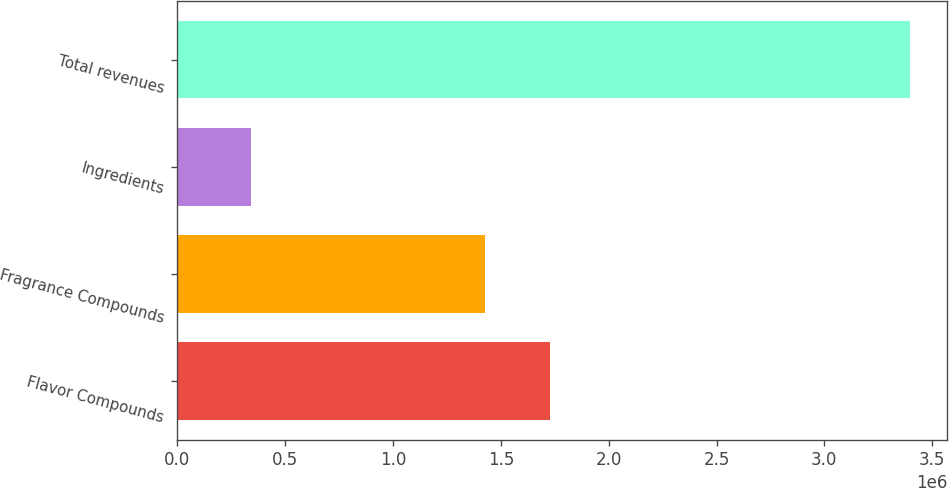Convert chart. <chart><loc_0><loc_0><loc_500><loc_500><bar_chart><fcel>Flavor Compounds<fcel>Fragrance Compounds<fcel>Ingredients<fcel>Total revenues<nl><fcel>1.73029e+06<fcel>1.42461e+06<fcel>341941<fcel>3.39872e+06<nl></chart> 